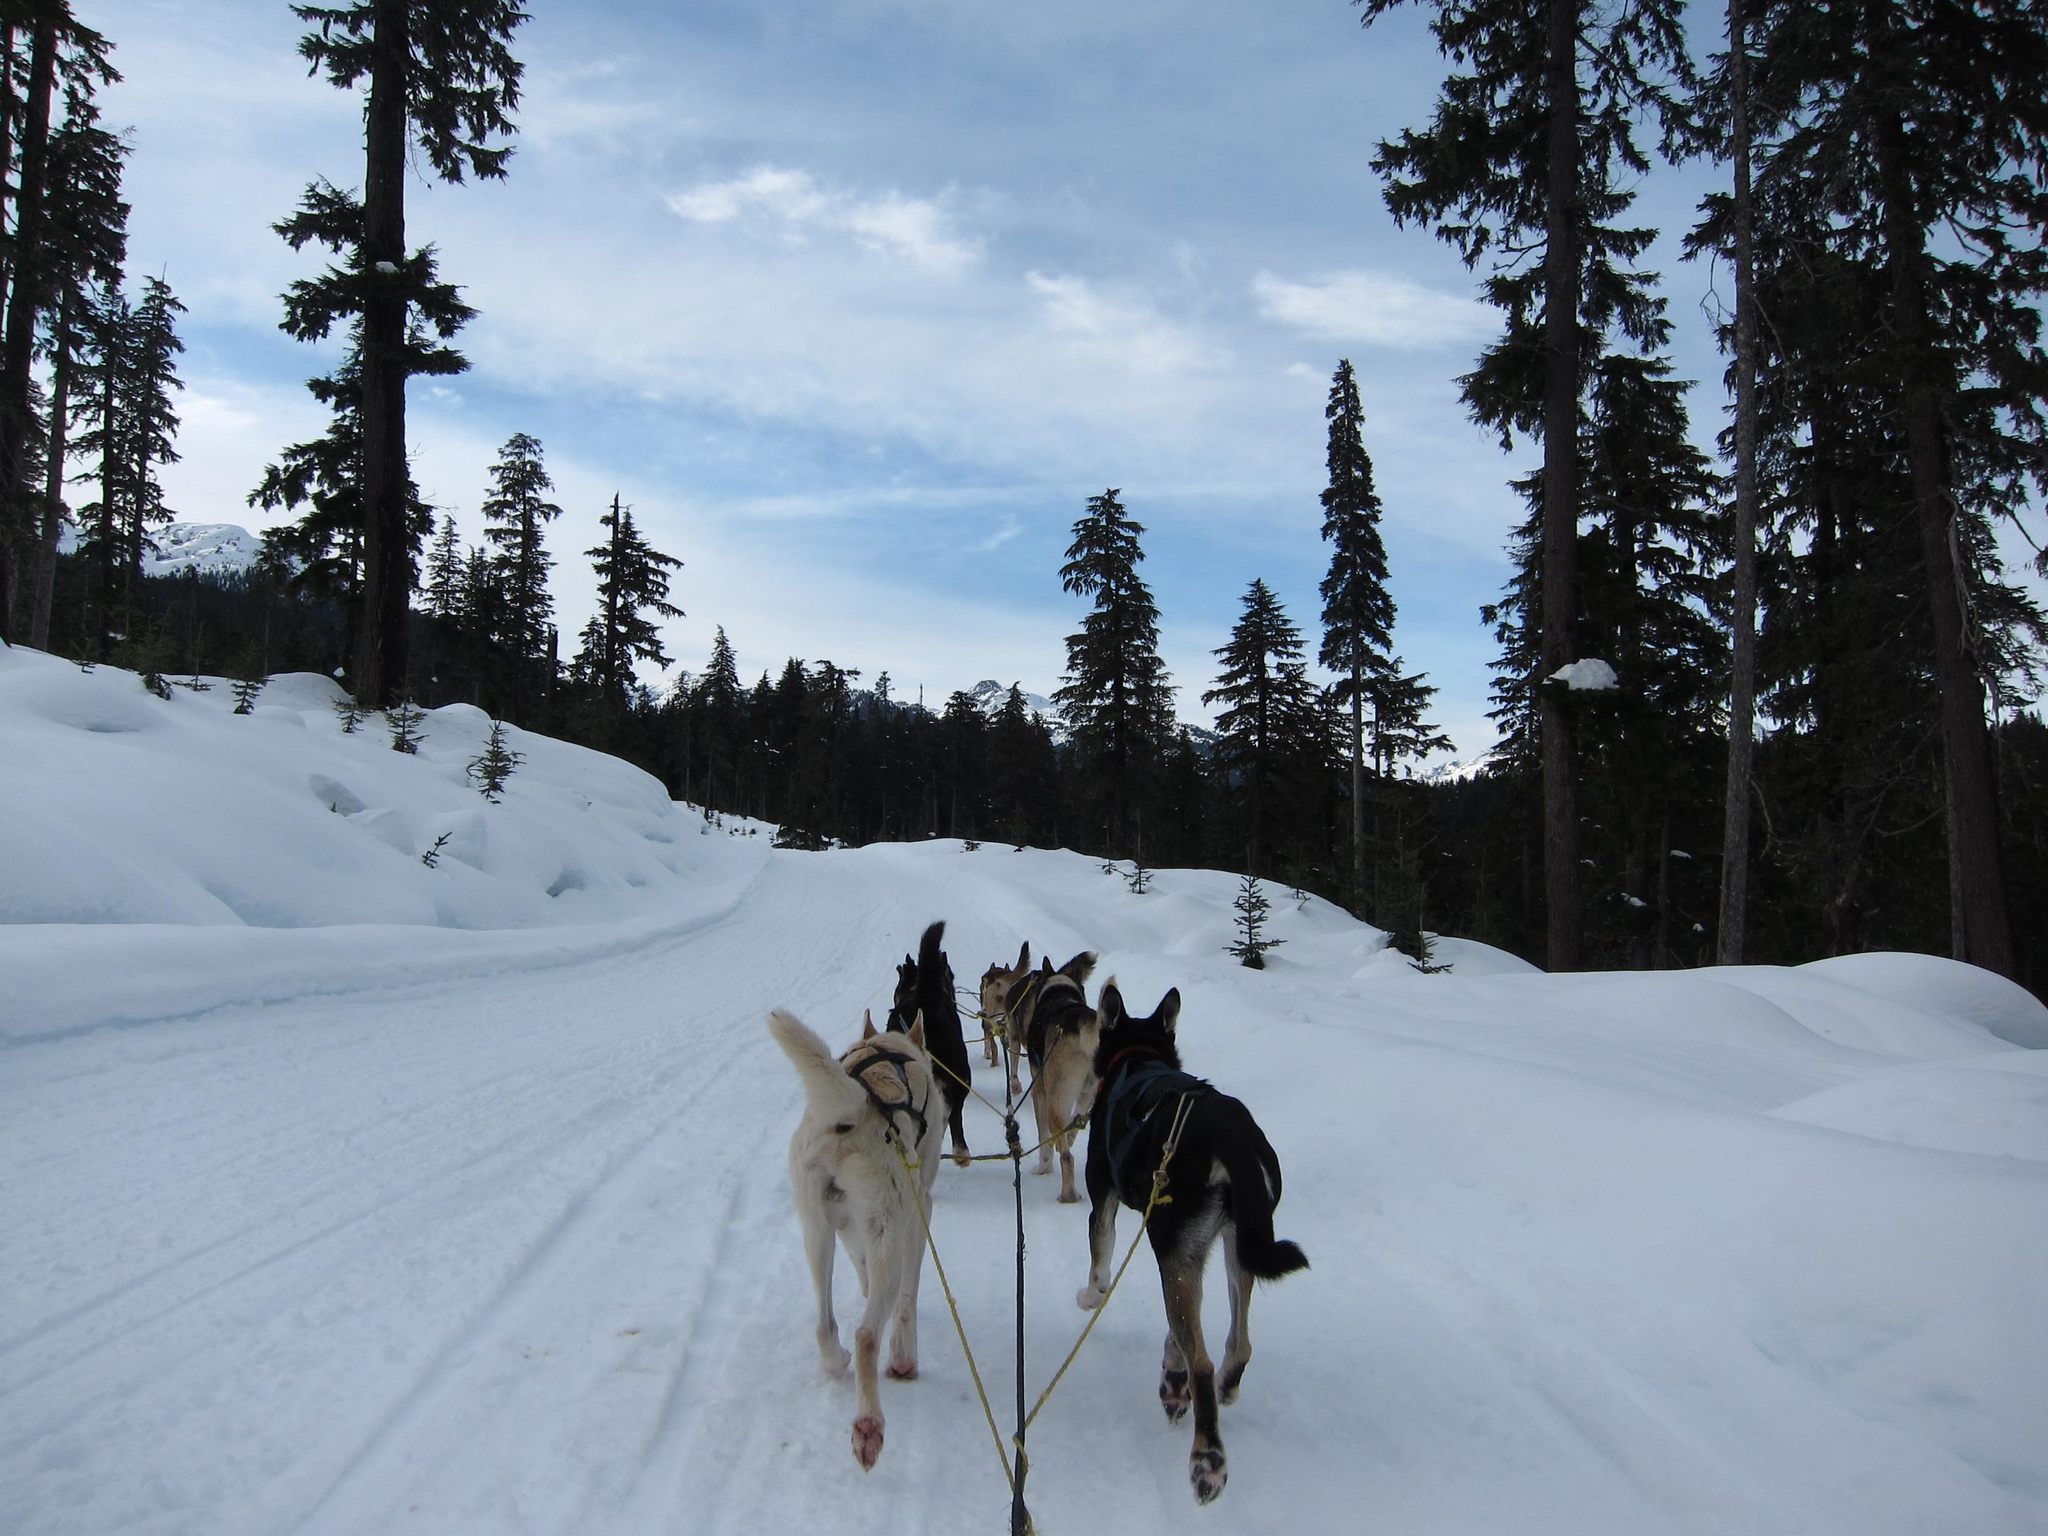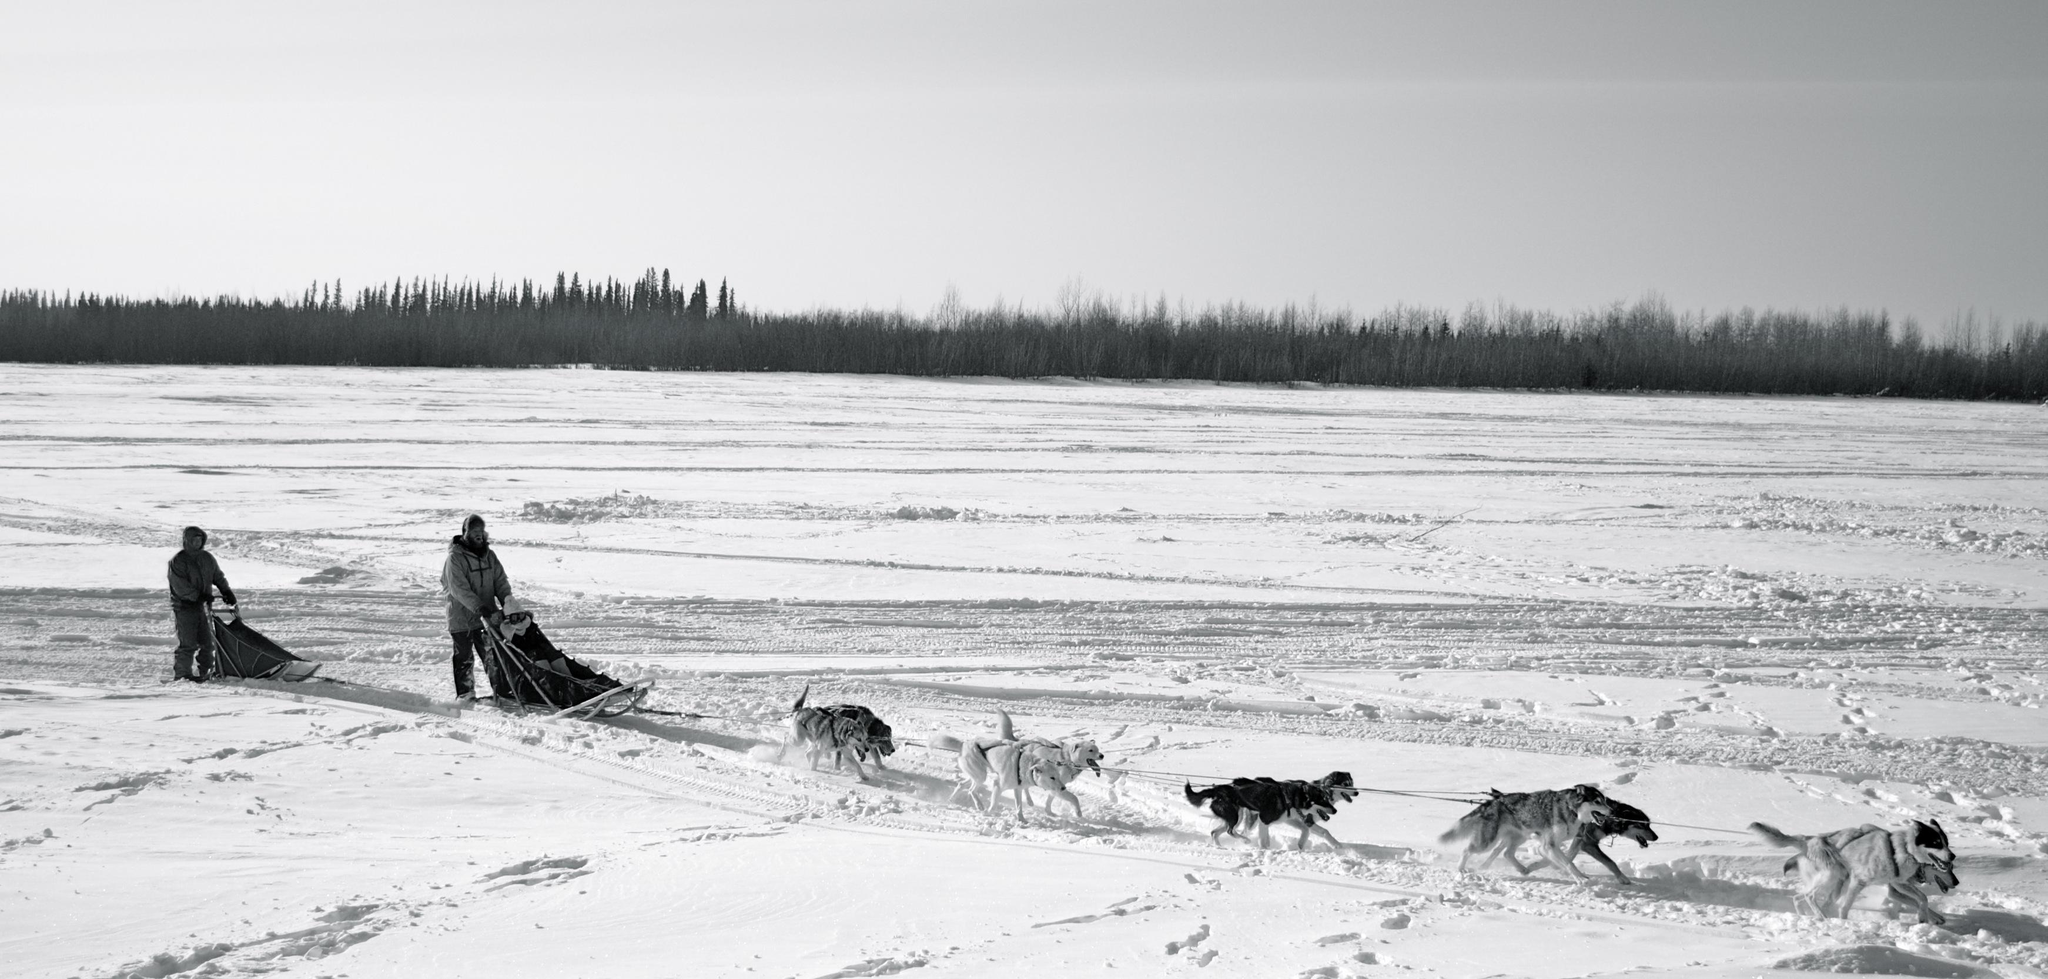The first image is the image on the left, the second image is the image on the right. Considering the images on both sides, is "In at least one photo, the dogs are running." valid? Answer yes or no. Yes. The first image is the image on the left, the second image is the image on the right. Evaluate the accuracy of this statement regarding the images: "There are no more than 2 people present, dog sledding.". Is it true? Answer yes or no. Yes. 